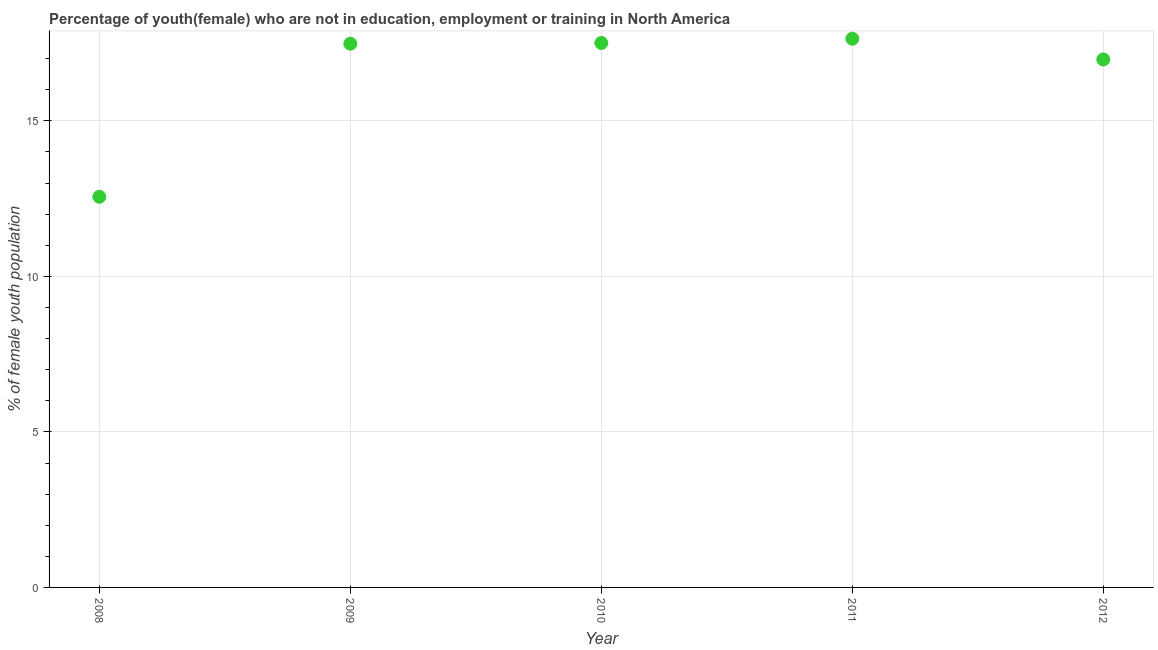What is the unemployed female youth population in 2009?
Offer a terse response. 17.48. Across all years, what is the maximum unemployed female youth population?
Give a very brief answer. 17.64. Across all years, what is the minimum unemployed female youth population?
Give a very brief answer. 12.56. In which year was the unemployed female youth population maximum?
Your answer should be very brief. 2011. What is the sum of the unemployed female youth population?
Your answer should be compact. 82.16. What is the difference between the unemployed female youth population in 2009 and 2011?
Keep it short and to the point. -0.16. What is the average unemployed female youth population per year?
Your answer should be compact. 16.43. What is the median unemployed female youth population?
Give a very brief answer. 17.48. What is the ratio of the unemployed female youth population in 2008 to that in 2011?
Give a very brief answer. 0.71. Is the difference between the unemployed female youth population in 2010 and 2012 greater than the difference between any two years?
Provide a short and direct response. No. What is the difference between the highest and the second highest unemployed female youth population?
Your response must be concise. 0.14. Is the sum of the unemployed female youth population in 2009 and 2010 greater than the maximum unemployed female youth population across all years?
Give a very brief answer. Yes. What is the difference between the highest and the lowest unemployed female youth population?
Provide a short and direct response. 5.08. How many dotlines are there?
Offer a very short reply. 1. Are the values on the major ticks of Y-axis written in scientific E-notation?
Offer a very short reply. No. Does the graph contain any zero values?
Keep it short and to the point. No. What is the title of the graph?
Your answer should be compact. Percentage of youth(female) who are not in education, employment or training in North America. What is the label or title of the Y-axis?
Your answer should be very brief. % of female youth population. What is the % of female youth population in 2008?
Keep it short and to the point. 12.56. What is the % of female youth population in 2009?
Your response must be concise. 17.48. What is the % of female youth population in 2010?
Provide a short and direct response. 17.5. What is the % of female youth population in 2011?
Make the answer very short. 17.64. What is the % of female youth population in 2012?
Your response must be concise. 16.97. What is the difference between the % of female youth population in 2008 and 2009?
Your response must be concise. -4.92. What is the difference between the % of female youth population in 2008 and 2010?
Give a very brief answer. -4.94. What is the difference between the % of female youth population in 2008 and 2011?
Ensure brevity in your answer.  -5.08. What is the difference between the % of female youth population in 2008 and 2012?
Keep it short and to the point. -4.42. What is the difference between the % of female youth population in 2009 and 2010?
Give a very brief answer. -0.02. What is the difference between the % of female youth population in 2009 and 2011?
Give a very brief answer. -0.16. What is the difference between the % of female youth population in 2009 and 2012?
Give a very brief answer. 0.51. What is the difference between the % of female youth population in 2010 and 2011?
Give a very brief answer. -0.14. What is the difference between the % of female youth population in 2010 and 2012?
Offer a very short reply. 0.53. What is the difference between the % of female youth population in 2011 and 2012?
Your response must be concise. 0.67. What is the ratio of the % of female youth population in 2008 to that in 2009?
Offer a very short reply. 0.72. What is the ratio of the % of female youth population in 2008 to that in 2010?
Offer a very short reply. 0.72. What is the ratio of the % of female youth population in 2008 to that in 2011?
Give a very brief answer. 0.71. What is the ratio of the % of female youth population in 2008 to that in 2012?
Provide a short and direct response. 0.74. What is the ratio of the % of female youth population in 2009 to that in 2012?
Keep it short and to the point. 1.03. What is the ratio of the % of female youth population in 2010 to that in 2011?
Make the answer very short. 0.99. What is the ratio of the % of female youth population in 2010 to that in 2012?
Provide a succinct answer. 1.03. What is the ratio of the % of female youth population in 2011 to that in 2012?
Give a very brief answer. 1.04. 